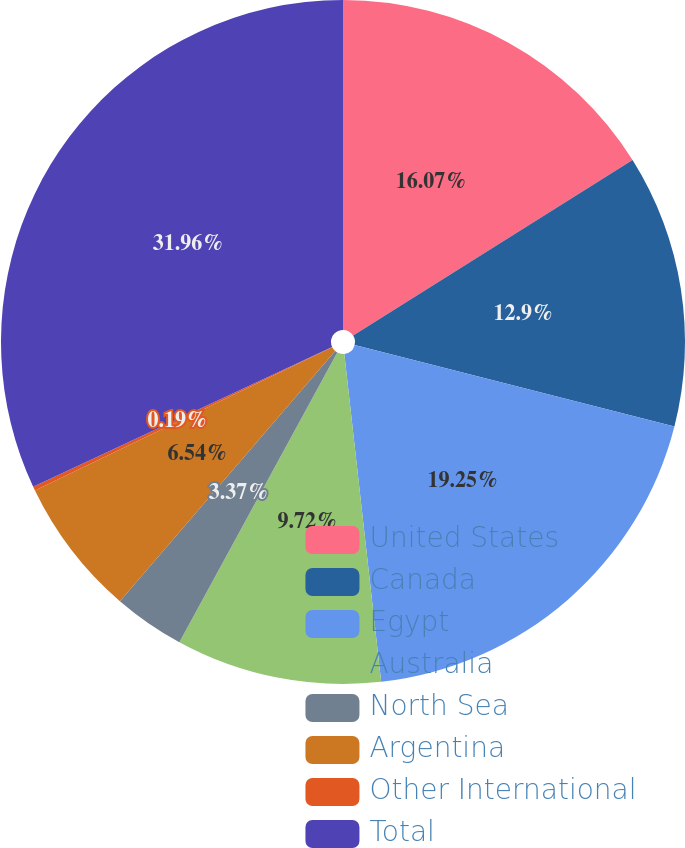Convert chart to OTSL. <chart><loc_0><loc_0><loc_500><loc_500><pie_chart><fcel>United States<fcel>Canada<fcel>Egypt<fcel>Australia<fcel>North Sea<fcel>Argentina<fcel>Other International<fcel>Total<nl><fcel>16.07%<fcel>12.9%<fcel>19.25%<fcel>9.72%<fcel>3.37%<fcel>6.54%<fcel>0.19%<fcel>31.96%<nl></chart> 